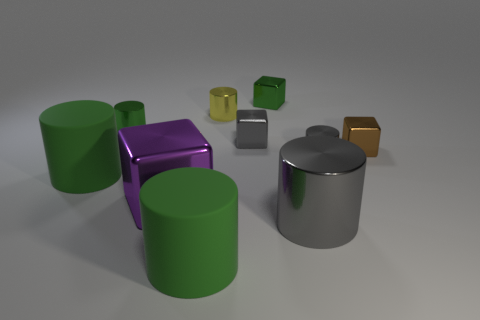Is the small gray cylinder made of the same material as the gray thing that is behind the small gray cylinder?
Offer a very short reply. Yes. What color is the shiny block behind the small gray object that is to the left of the tiny metal thing in front of the small brown block?
Ensure brevity in your answer.  Green. There is a gray block that is the same size as the brown metal object; what is its material?
Provide a succinct answer. Metal. How many tiny green cylinders have the same material as the small yellow cylinder?
Offer a very short reply. 1. Does the gray metallic cylinder in front of the small gray cylinder have the same size as the green matte cylinder that is left of the big purple metallic object?
Provide a short and direct response. Yes. What is the color of the metallic thing that is to the left of the purple block?
Offer a terse response. Green. There is a cube that is the same color as the large metallic cylinder; what is its material?
Offer a very short reply. Metal. What number of objects are the same color as the large shiny cylinder?
Provide a short and direct response. 2. There is a yellow shiny thing; is it the same size as the shiny cylinder to the left of the big purple metal cube?
Ensure brevity in your answer.  Yes. How big is the green thing on the left side of the green cylinder that is behind the tiny brown block in front of the gray shiny block?
Ensure brevity in your answer.  Large. 